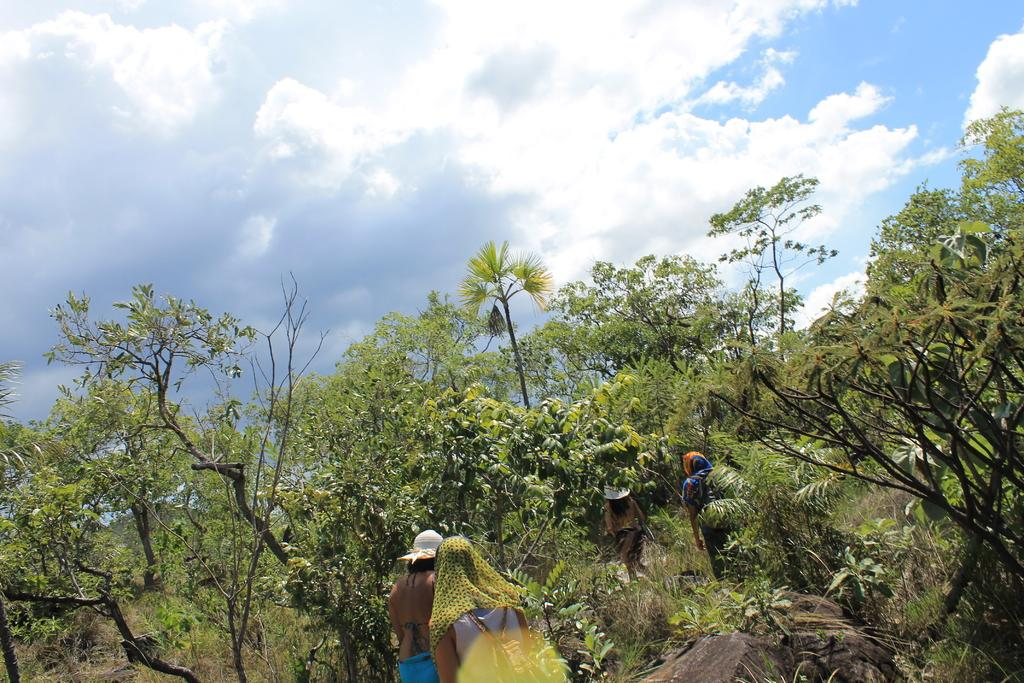How many people are in the image? There are four tribal people in the image. What are the people doing in the image? The people are walking on the ground. What type of vegetation can be seen in the image? There are trees visible in the image. What is visible in the sky in the image? There are clouds in the sky. What type of moon can be seen in the image? There is no moon visible in the image; only clouds can be seen in the sky. How tall are the giants in the image? There are no giants present in the image; only four tribal people are visible. 